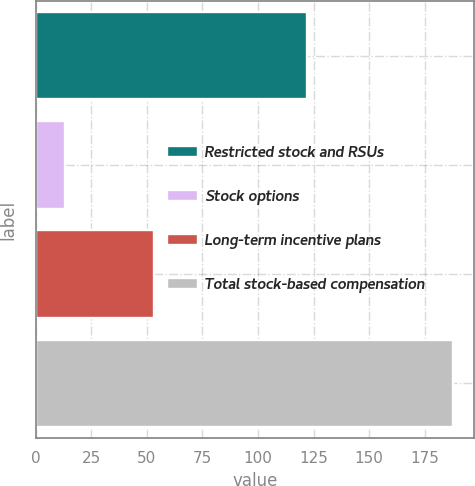Convert chart to OTSL. <chart><loc_0><loc_0><loc_500><loc_500><bar_chart><fcel>Restricted stock and RSUs<fcel>Stock options<fcel>Long-term incentive plans<fcel>Total stock-based compensation<nl><fcel>122<fcel>13<fcel>53<fcel>188<nl></chart> 